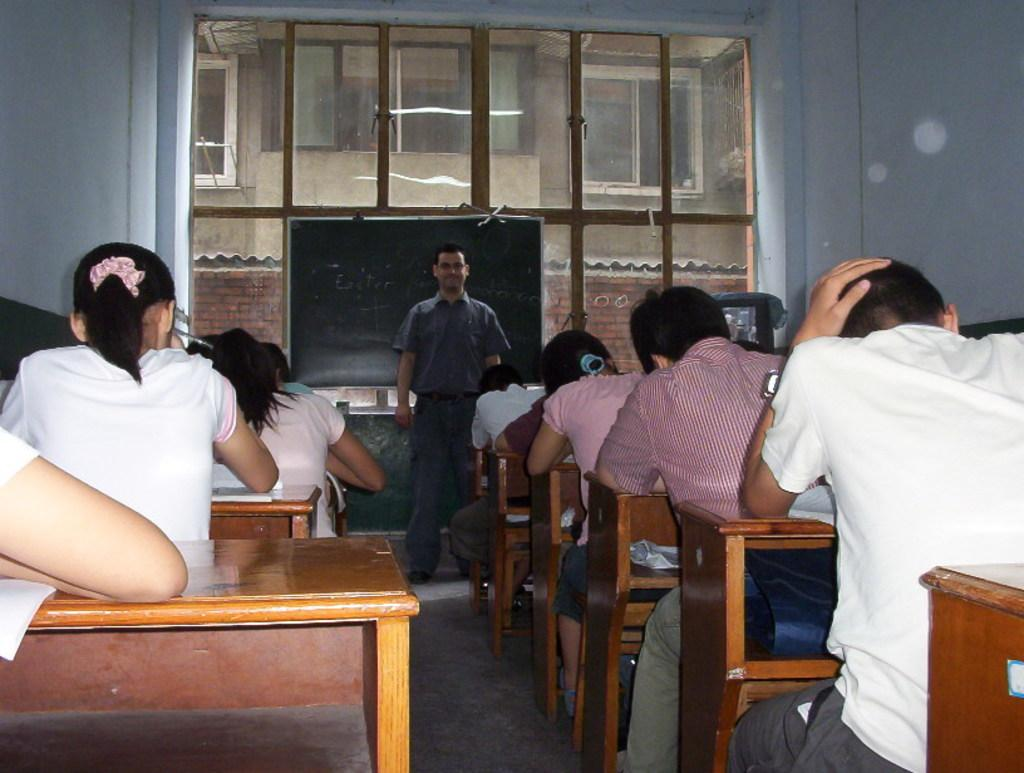What are the people in the image doing? There is a group of people sitting on chairs in the image. What is present on the table in the image? There is a table in the image, but no specific items are mentioned. What is the purpose of the blackboard in the image? The presence of a blackboard suggests that it might be used for writing or displaying information. What is the man in the image doing? A man is standing in the image, but his actions are not specified. What can be seen in the background of the image? There is a building in the background of the image. What type of soda is being distributed to the people in the image? There is no mention of soda or any distribution in the image. How many feet are visible in the image? The number of feet visible in the image cannot be determined from the provided facts. 